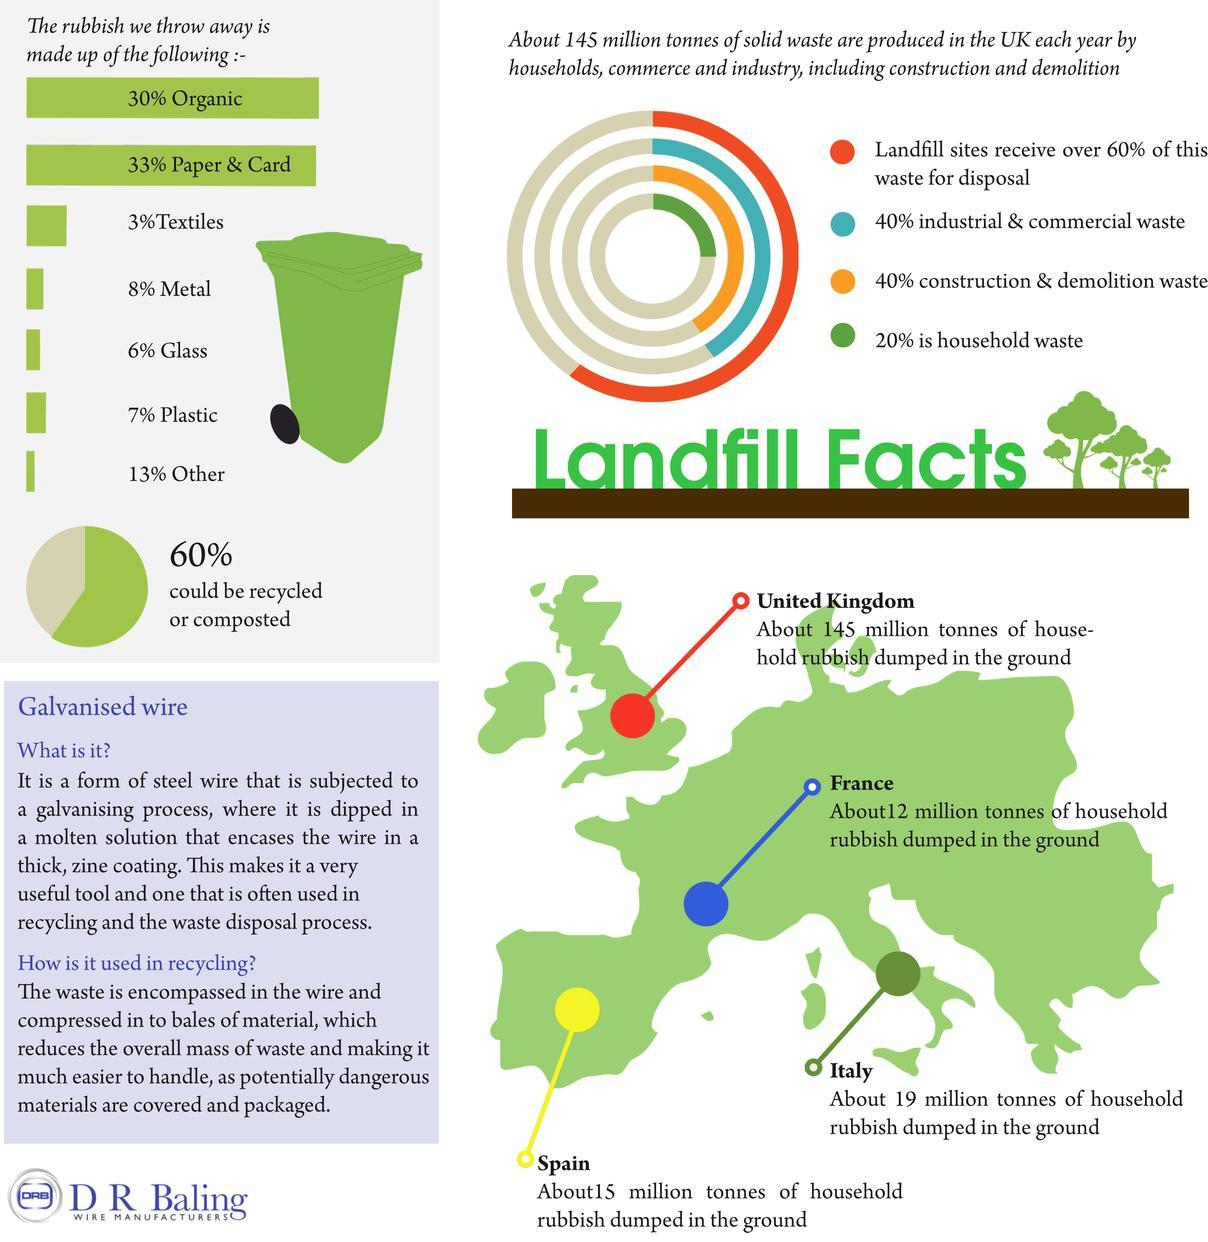Which country has a  comparatively higher rate of underground rubbish dumping , Spain France or Italy ?
Answer the question with a short phrase. France Which European country has the highest amount of household waste dumped in the ground? United Kingdom What percentage of waste cannot be recycled or composted ? 40% On the map what is the colour used to indicate the waste dumped by households in Spain - blue, green, yellow or red  ? Yellow By what percent is paper waste more than organic waste ? 3% By what percent is the metal waste more than the textile waste ? 5% What wire is often used in recycling ? Galvanized wire 